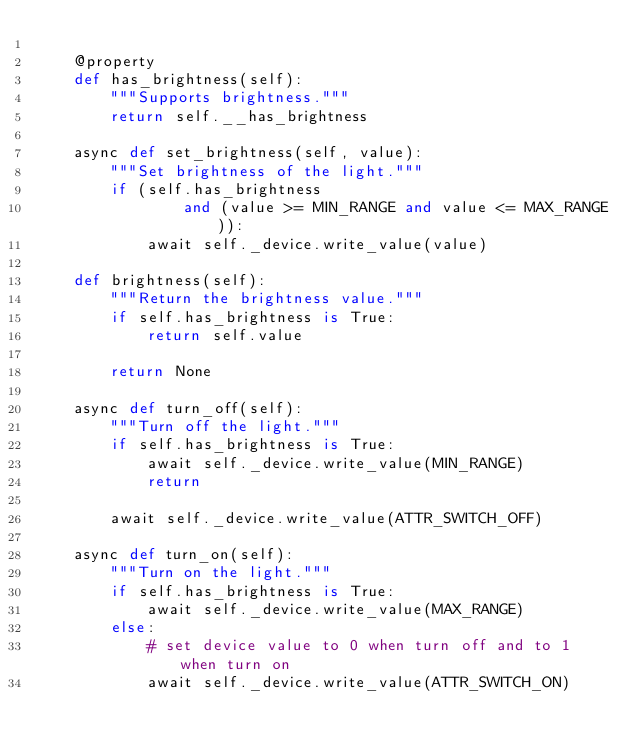Convert code to text. <code><loc_0><loc_0><loc_500><loc_500><_Python_>
    @property
    def has_brightness(self):
        """Supports brightness."""
        return self.__has_brightness

    async def set_brightness(self, value):
        """Set brightness of the light."""
        if (self.has_brightness
                and (value >= MIN_RANGE and value <= MAX_RANGE)):
            await self._device.write_value(value)

    def brightness(self):
        """Return the brightness value."""
        if self.has_brightness is True:
            return self.value

        return None

    async def turn_off(self):
        """Turn off the light."""
        if self.has_brightness is True:
            await self._device.write_value(MIN_RANGE)
            return

        await self._device.write_value(ATTR_SWITCH_OFF)

    async def turn_on(self):
        """Turn on the light."""
        if self.has_brightness is True:
            await self._device.write_value(MAX_RANGE)
        else:
            # set device value to 0 when turn off and to 1 when turn on
            await self._device.write_value(ATTR_SWITCH_ON)
</code> 